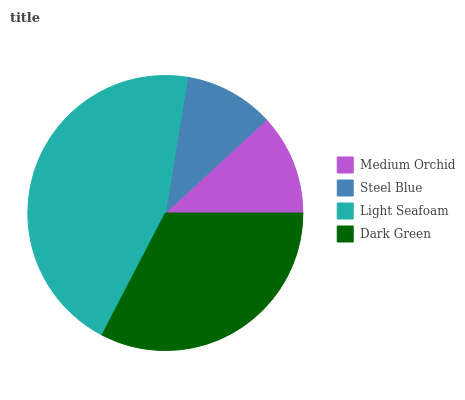Is Steel Blue the minimum?
Answer yes or no. Yes. Is Light Seafoam the maximum?
Answer yes or no. Yes. Is Light Seafoam the minimum?
Answer yes or no. No. Is Steel Blue the maximum?
Answer yes or no. No. Is Light Seafoam greater than Steel Blue?
Answer yes or no. Yes. Is Steel Blue less than Light Seafoam?
Answer yes or no. Yes. Is Steel Blue greater than Light Seafoam?
Answer yes or no. No. Is Light Seafoam less than Steel Blue?
Answer yes or no. No. Is Dark Green the high median?
Answer yes or no. Yes. Is Medium Orchid the low median?
Answer yes or no. Yes. Is Steel Blue the high median?
Answer yes or no. No. Is Dark Green the low median?
Answer yes or no. No. 